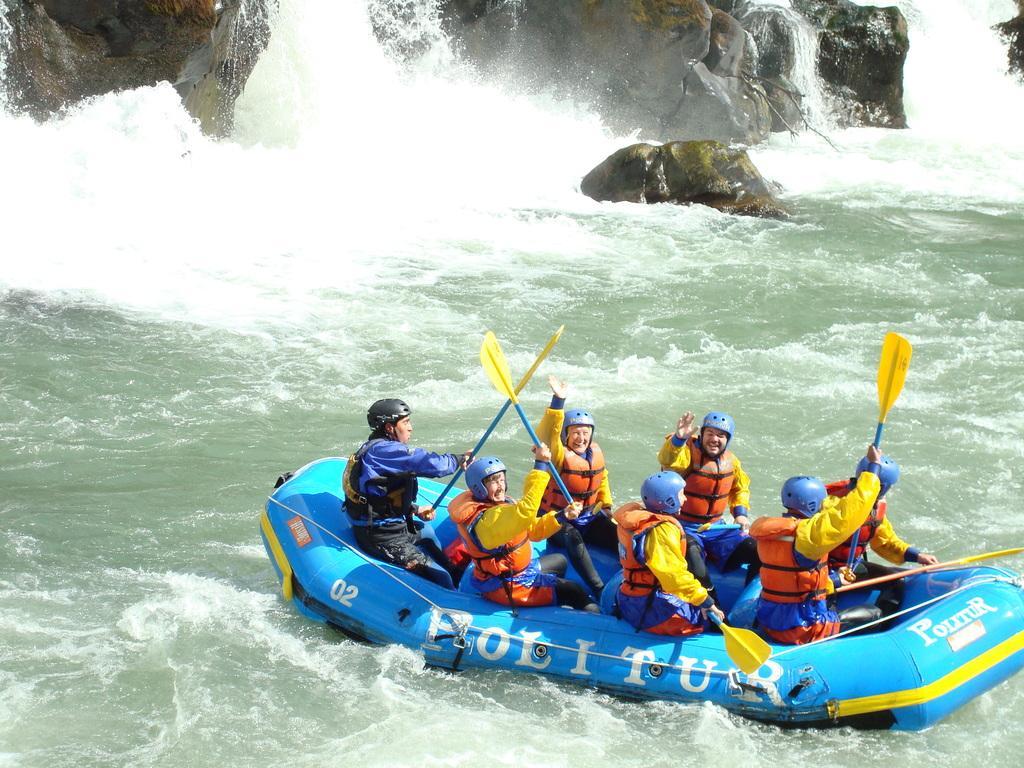In one or two sentences, can you explain what this image depicts? In this image we can see a few people sitting on the boat, among them some are holding the objects, also we can see some rocks and water. 